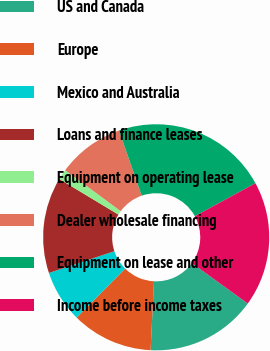<chart> <loc_0><loc_0><loc_500><loc_500><pie_chart><fcel>US and Canada<fcel>Europe<fcel>Mexico and Australia<fcel>Loans and finance leases<fcel>Equipment on operating lease<fcel>Dealer wholesale financing<fcel>Equipment on lease and other<fcel>Income before income taxes<nl><fcel>15.82%<fcel>11.64%<fcel>7.46%<fcel>13.73%<fcel>1.49%<fcel>9.55%<fcel>22.39%<fcel>17.91%<nl></chart> 